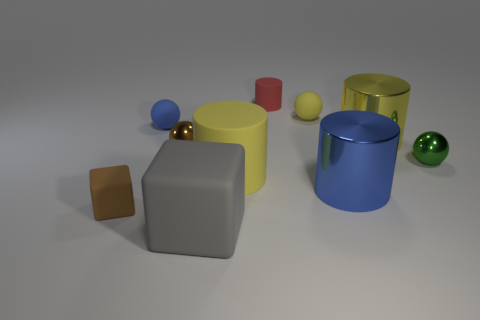Are there an equal number of small yellow balls that are in front of the big rubber cylinder and tiny brown rubber spheres?
Your response must be concise. Yes. How many small objects are on the right side of the brown matte object and on the left side of the blue metallic cylinder?
Provide a succinct answer. 4. Do the small green shiny object behind the small brown matte cube and the small blue rubber thing have the same shape?
Keep it short and to the point. Yes. There is a brown cube that is the same size as the blue matte thing; what material is it?
Provide a succinct answer. Rubber. Are there an equal number of small blue rubber objects that are on the right side of the small blue sphere and large yellow cylinders in front of the large yellow metallic cylinder?
Your answer should be very brief. No. There is a blue thing that is behind the large yellow cylinder on the left side of the small matte cylinder; what number of brown shiny things are in front of it?
Give a very brief answer. 1. There is a tiny matte block; does it have the same color as the small rubber ball that is left of the large gray thing?
Make the answer very short. No. What size is the green sphere that is made of the same material as the brown sphere?
Provide a succinct answer. Small. Are there more tiny metallic objects that are on the left side of the green thing than tiny cyan shiny balls?
Your answer should be compact. Yes. There is a small object that is to the right of the tiny rubber sphere to the right of the blue object left of the yellow sphere; what is its material?
Your response must be concise. Metal. 